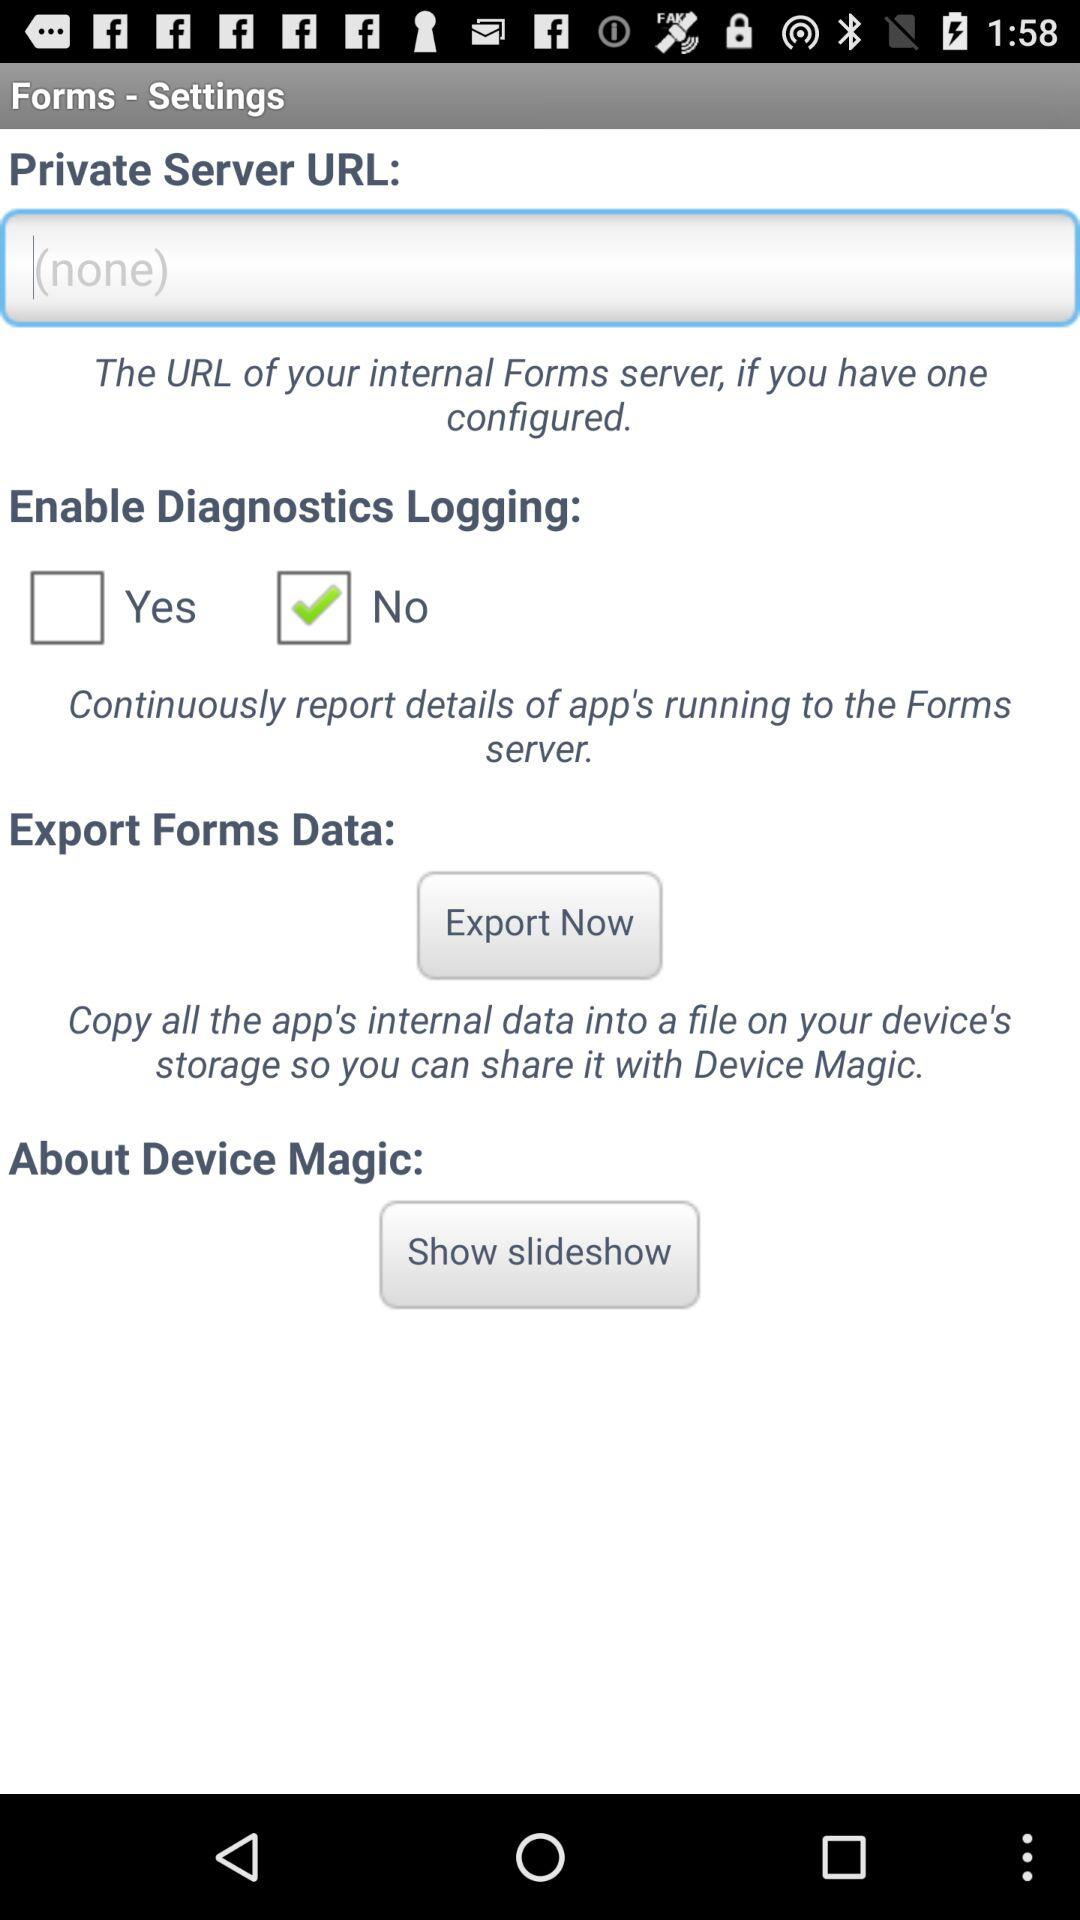What is the status of "Enable Diagnostics Logging"? The status of "Enable Diagnostics Logging" is "No". 